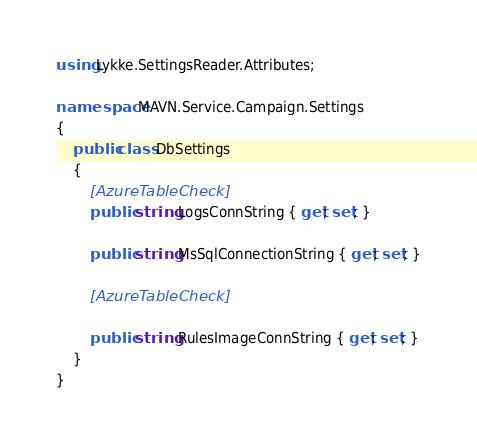<code> <loc_0><loc_0><loc_500><loc_500><_C#_>using Lykke.SettingsReader.Attributes;

namespace MAVN.Service.Campaign.Settings
{
    public class DbSettings
    {
        [AzureTableCheck]
        public string LogsConnString { get; set; }

        public string MsSqlConnectionString { get; set; }

        [AzureTableCheck]

        public string RulesImageConnString { get; set; }
    }
}
</code> 